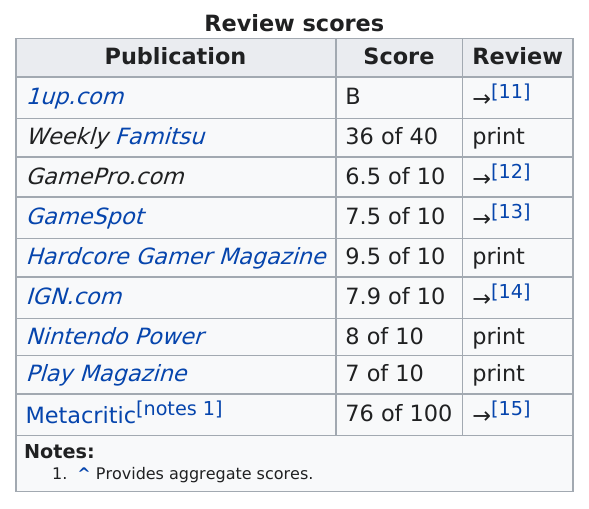Identify some key points in this picture. The total number of publications is 9. Before Play Magazine, Nintendo Power is a publication that is highly regarded. Four publications are indicated as being in print. Six publications used a scale-of-one-to-ten scoring system. I'm sorry, but I'm not sure what you are asking. Could you please provide more context or clarify your question? 